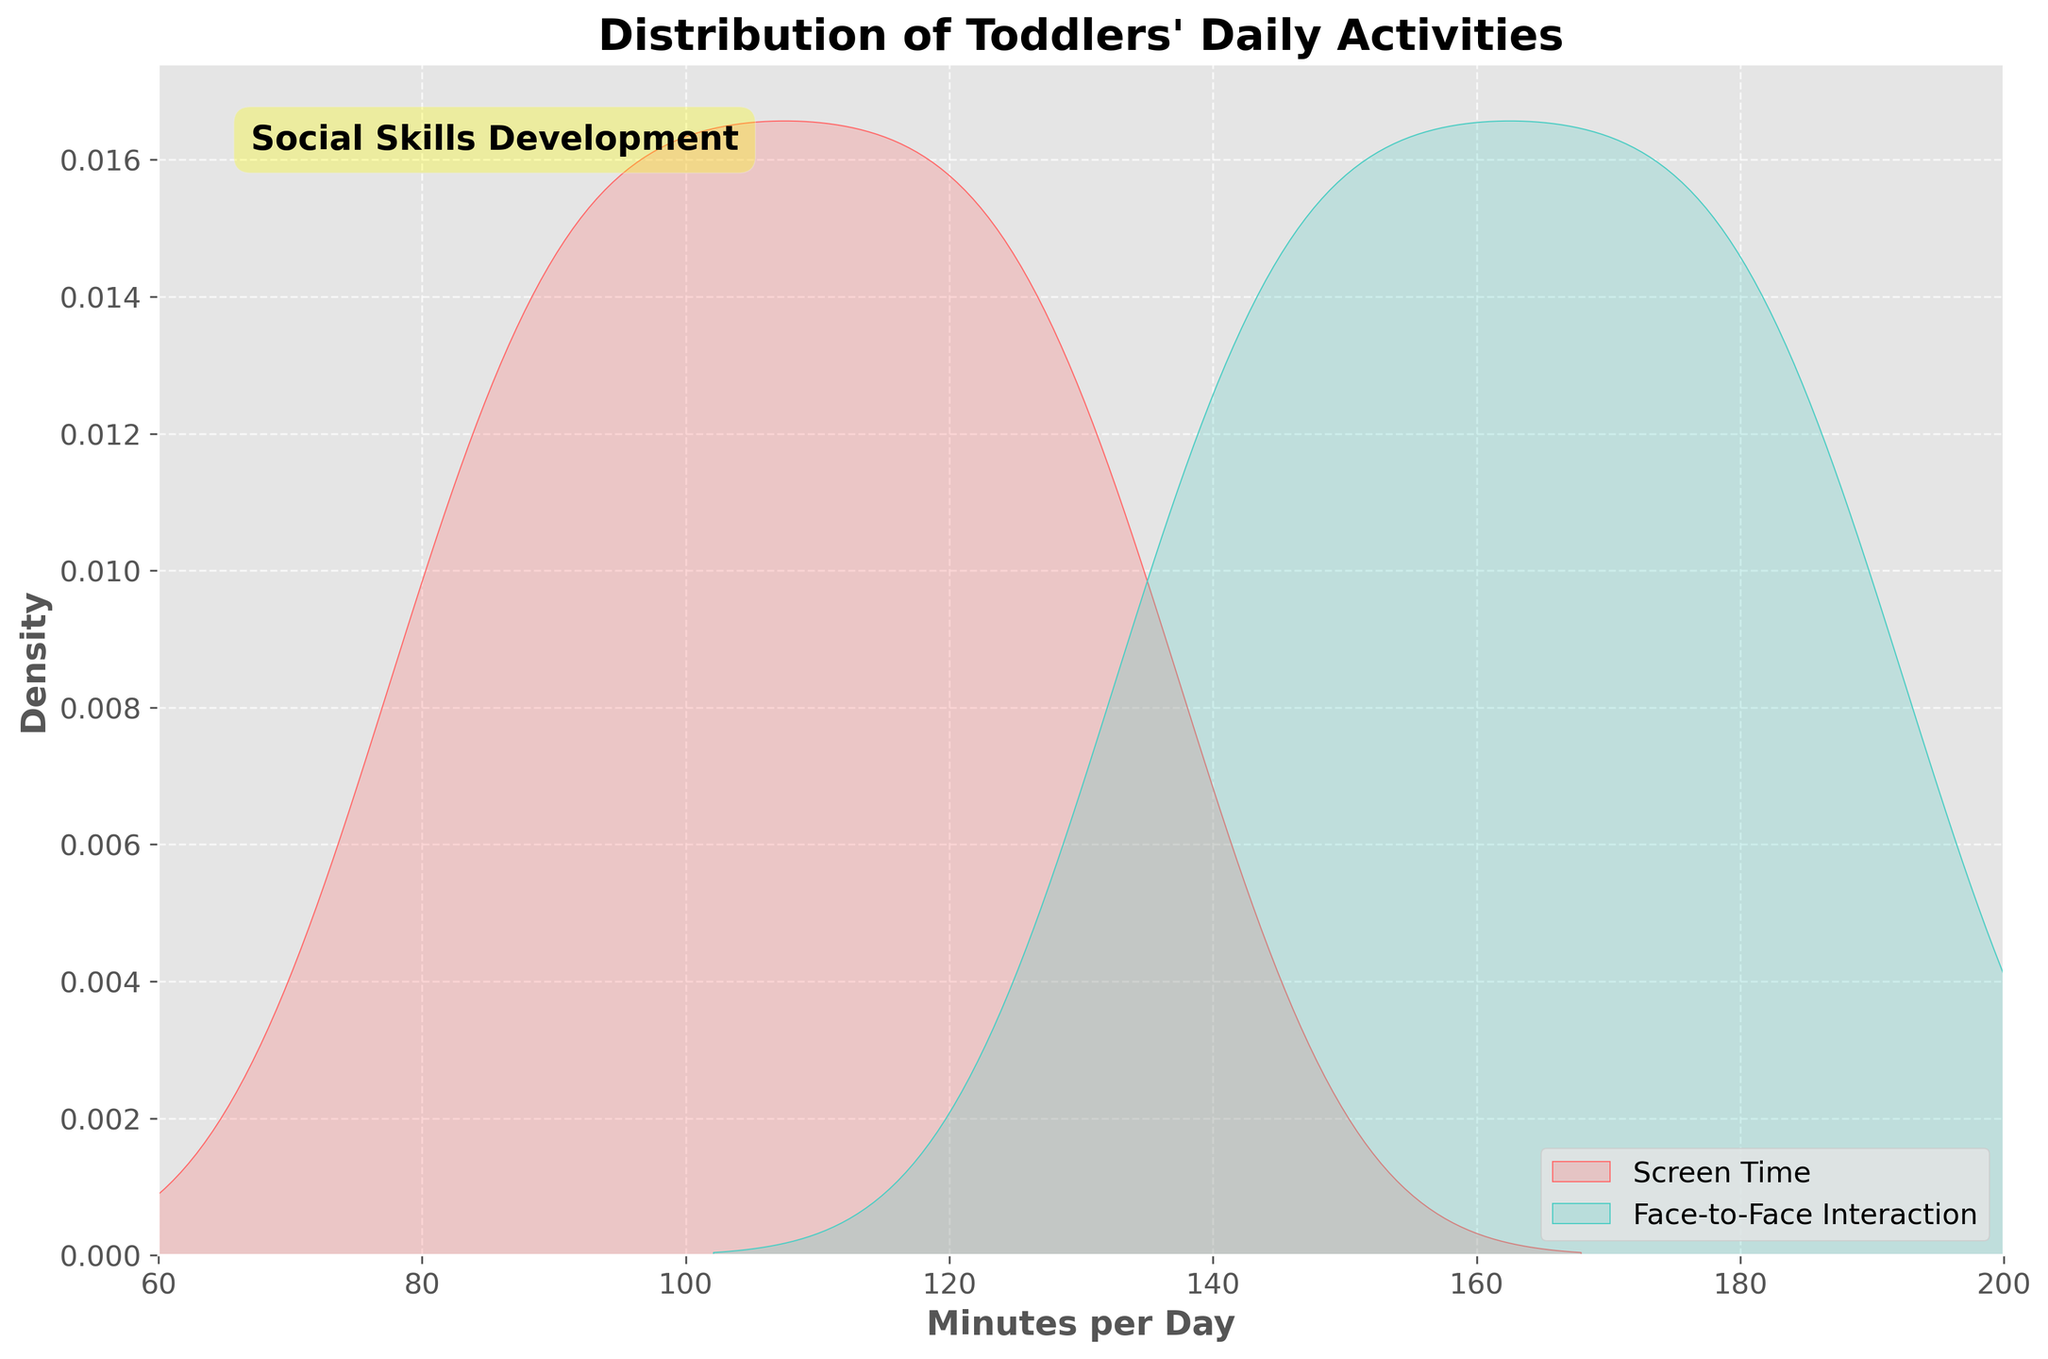What is the title of the figure? The title is usually prominently displayed at the top of the figure and helps describe what the figure is about.
Answer: Distribution of Toddlers' Daily Activities What are the labels on the x-axis and y-axis? The labels on the axes help understand what each axis represents. The x-axis typically represents the variable being measured, and the y-axis represents the frequency or density.
Answer: Minutes per Day and Density What colors represent Screen Time and Face-to-Face Interaction? The colors used in the plot differentiate between the two types of activities.
Answer: Screen Time is red, and Face-to-Face Interaction is teal What is the range of minutes per day represented on the x-axis? To determine the range, look at the minimum and maximum values on the x-axis.
Answer: 60 to 200 minutes Which activity has a higher peak density in the distribution? By comparing the height of the peaks in the two density curves, we can see which activity has a higher peak.
Answer: Face-to-Face Interaction Are there any toddlers who spend more than 180 minutes per day on Face-to-Face Interaction? To determine this, observe the tail end of the Face-to-Face Interaction distribution.
Answer: Yes How do Screen Time and Face-to-Face Interaction compare in terms of variability? Variability can be judged by looking at the spread of each distribution curve. Wider spreads indicate higher variability.
Answer: Screen Time has more variability What are the modes of Screen Time and Face-to-Face Interaction in minutes per day? The mode is the value where each distribution has its peak.
Answer: Screen Time is around 110 minutes, Face-to-Face Interaction is around 170 minutes How often do toddlers spend between 120 and 130 minutes per day on both activities? Compare the density curves in the specified range to see the relative likelihood.
Answer: Less likely for Screen Time, more likely for Face-to-Face Interaction 